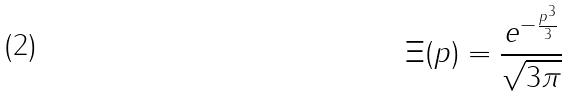<formula> <loc_0><loc_0><loc_500><loc_500>\Xi ( p ) = \frac { e ^ { - \frac { p ^ { 3 } } { 3 } } } { \sqrt { 3 \pi } }</formula> 